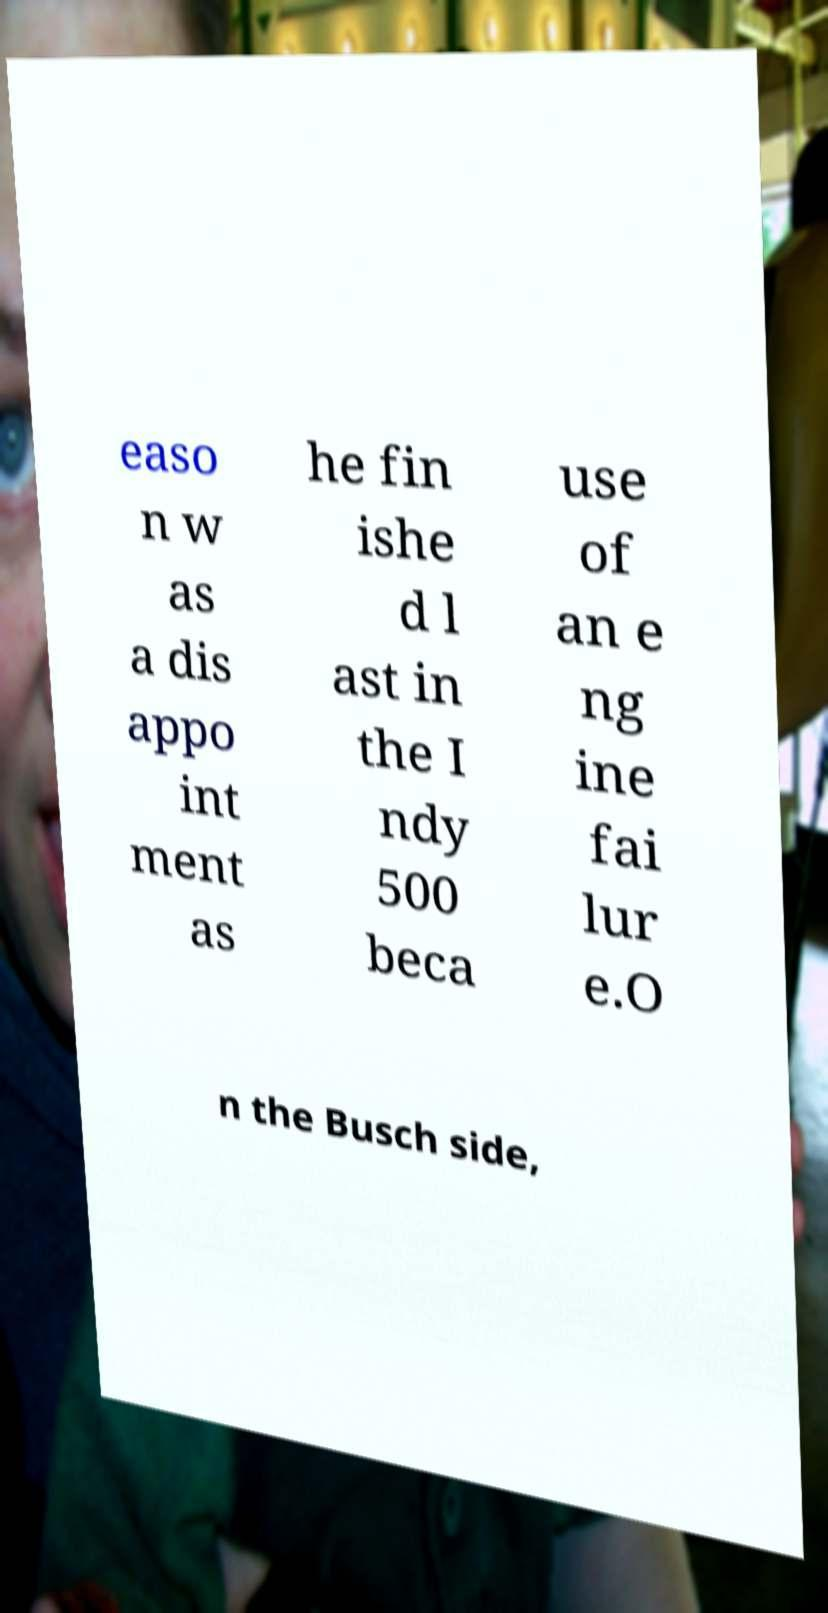What messages or text are displayed in this image? I need them in a readable, typed format. easo n w as a dis appo int ment as he fin ishe d l ast in the I ndy 500 beca use of an e ng ine fai lur e.O n the Busch side, 